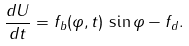<formula> <loc_0><loc_0><loc_500><loc_500>\frac { d U } { d t } = f _ { b } ( \varphi , t ) \, \sin \varphi - f _ { d } .</formula> 